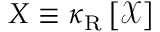<formula> <loc_0><loc_0><loc_500><loc_500>X \equiv \kappa _ { R } \left [ \mathcal { X } \right ]</formula> 